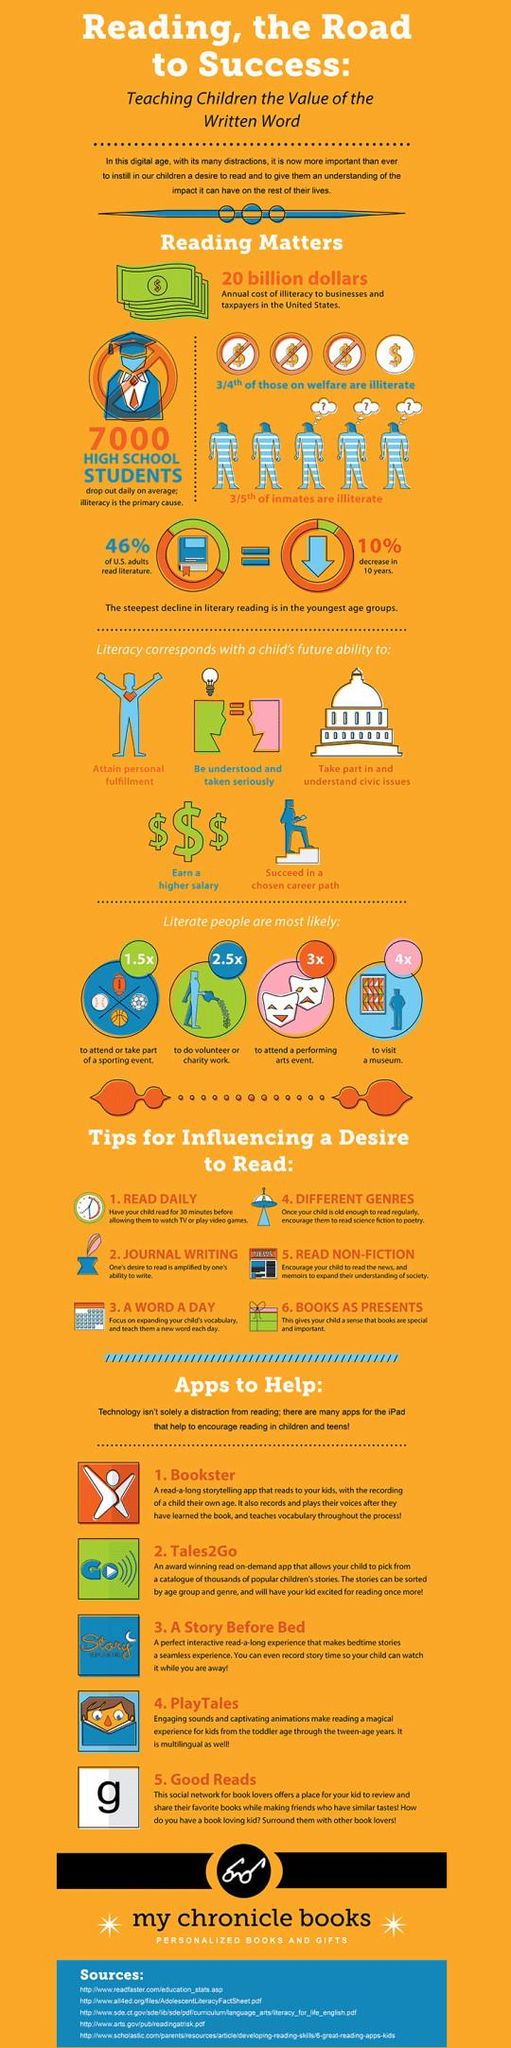Specify some key components in this picture. It is evident that literacy is closely linked to a child's future academic and professional success, as it is a fundamental skill required for reading, writing, and critical thinking. According to a recent survey, 54% of adults in the United States did not read literature. 